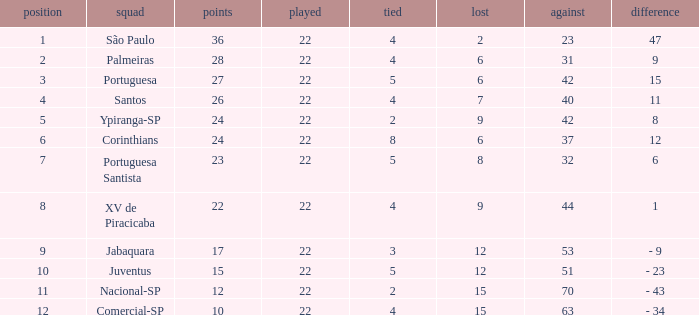Which Against has a Drawn smaller than 5, and a Lost smaller than 6, and a Points larger than 36? 0.0. 